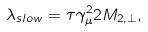<formula> <loc_0><loc_0><loc_500><loc_500>\lambda _ { s l o w } = \tau \gamma ^ { 2 } _ { \mu } 2 M _ { 2 , \perp } ,</formula> 